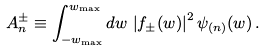<formula> <loc_0><loc_0><loc_500><loc_500>A _ { n } ^ { \pm } \equiv \int _ { - w _ { \max } } ^ { w _ { \max } } d w \, \left | f _ { \pm } ( w ) \right | ^ { 2 } \psi _ { ( n ) } ( w ) \, .</formula> 